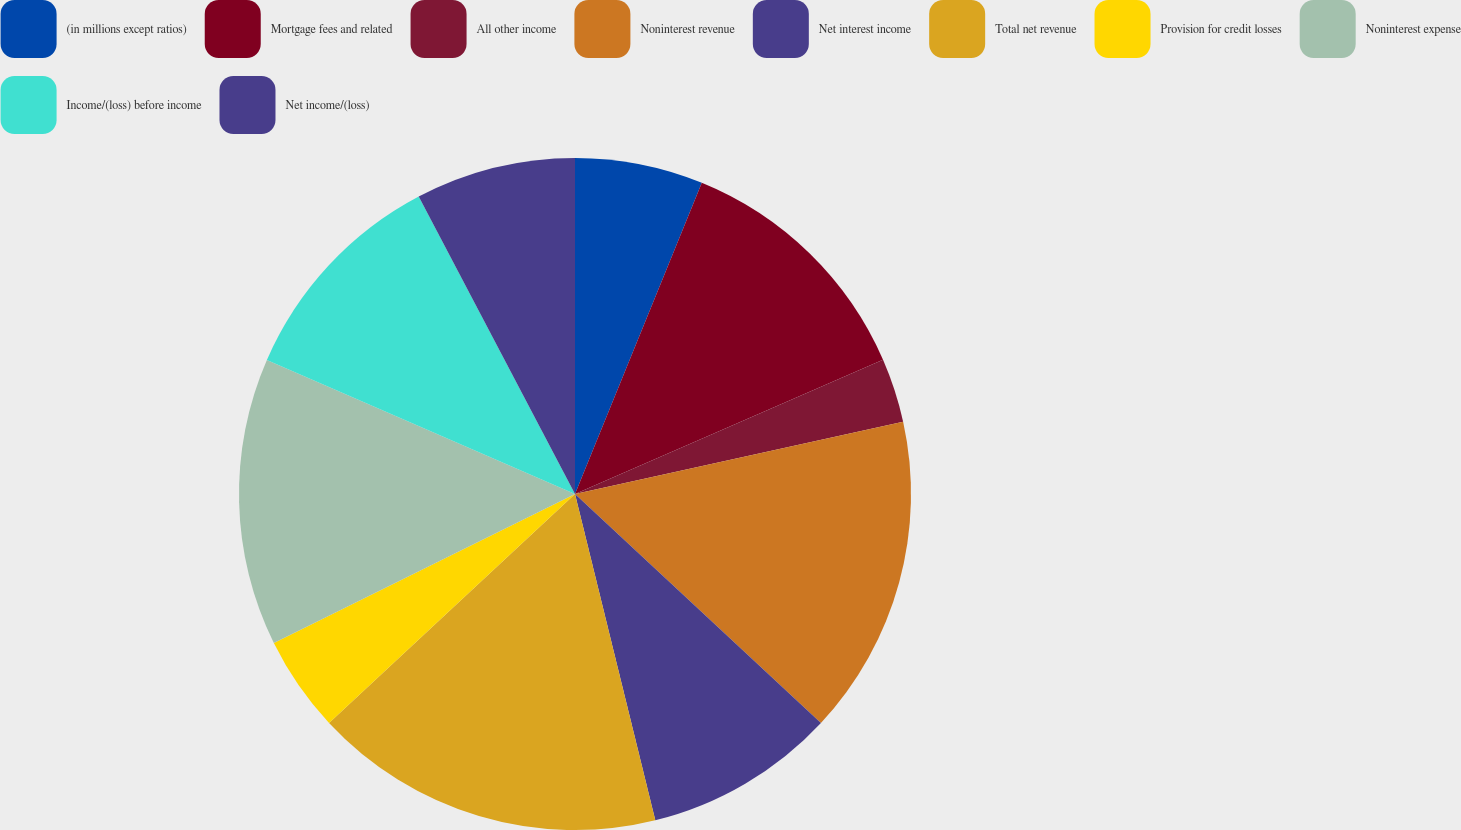Convert chart to OTSL. <chart><loc_0><loc_0><loc_500><loc_500><pie_chart><fcel>(in millions except ratios)<fcel>Mortgage fees and related<fcel>All other income<fcel>Noninterest revenue<fcel>Net interest income<fcel>Total net revenue<fcel>Provision for credit losses<fcel>Noninterest expense<fcel>Income/(loss) before income<fcel>Net income/(loss)<nl><fcel>6.16%<fcel>12.3%<fcel>3.09%<fcel>15.38%<fcel>9.23%<fcel>16.91%<fcel>4.62%<fcel>13.84%<fcel>10.77%<fcel>7.7%<nl></chart> 